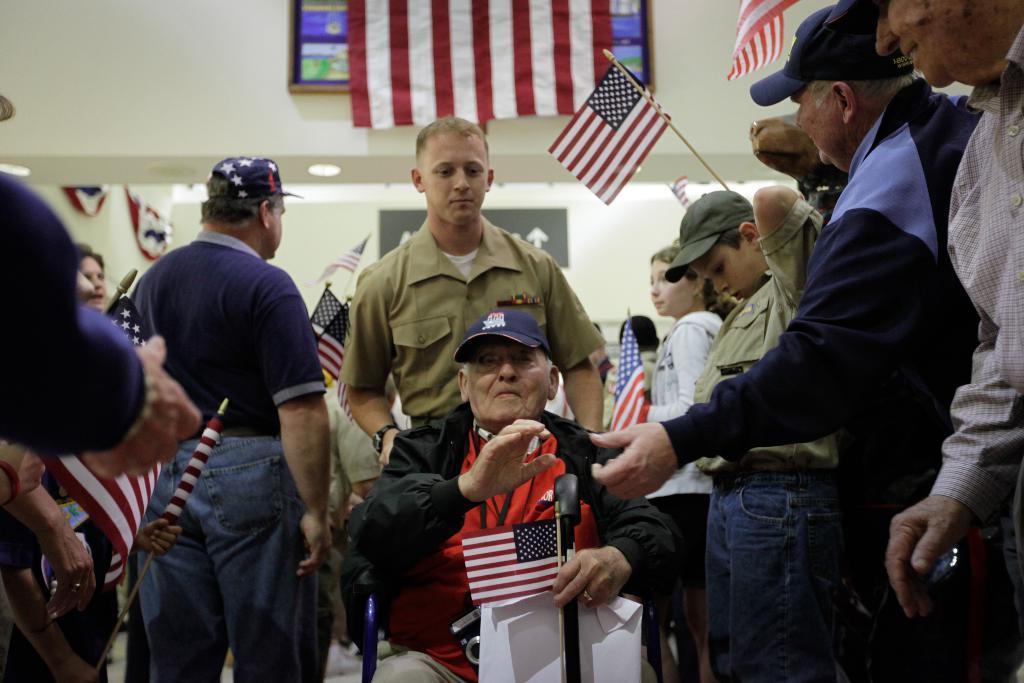Can you describe this image briefly? In the picture we can see a man in the wheel chair and one man is holding it and around him we can see many people are standing and holding a USA national flag in the hands and in the background we can see the wall and a part of the wall with a flag to it. 